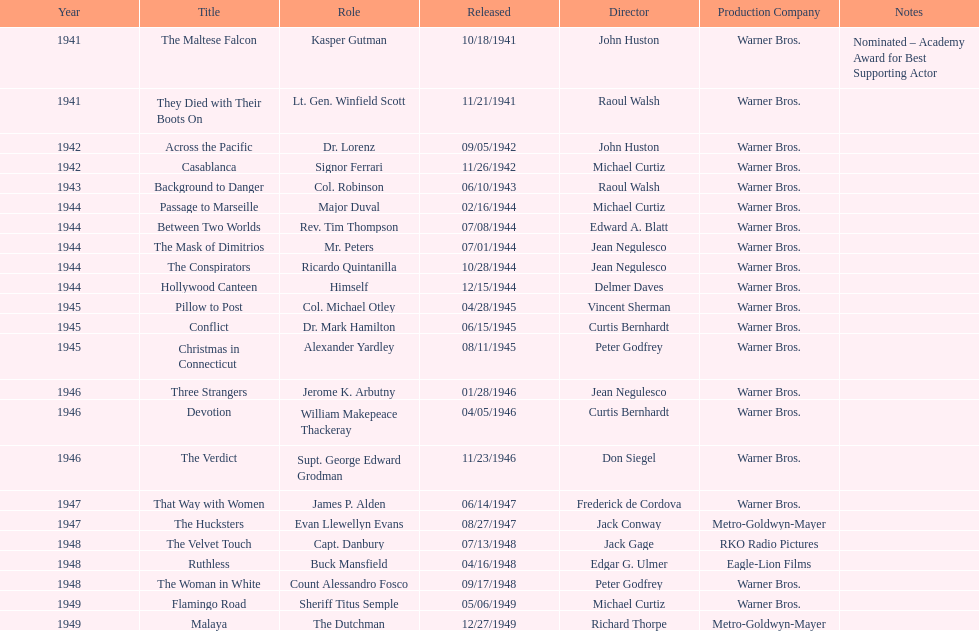In which movie did he earn a nomination for an academy award? The Maltese Falcon. 